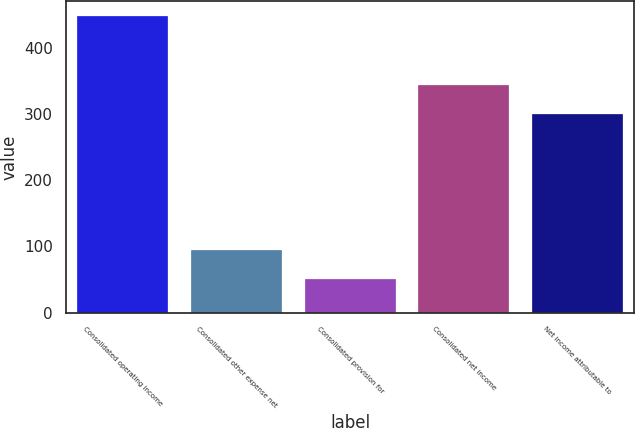<chart> <loc_0><loc_0><loc_500><loc_500><bar_chart><fcel>Consolidated operating income<fcel>Consolidated other expense net<fcel>Consolidated provision for<fcel>Consolidated net income<fcel>Net income attributable to<nl><fcel>448<fcel>94.8<fcel>50.65<fcel>343.95<fcel>299.8<nl></chart> 